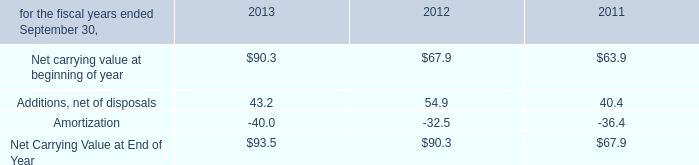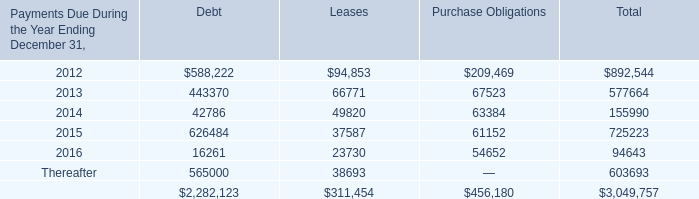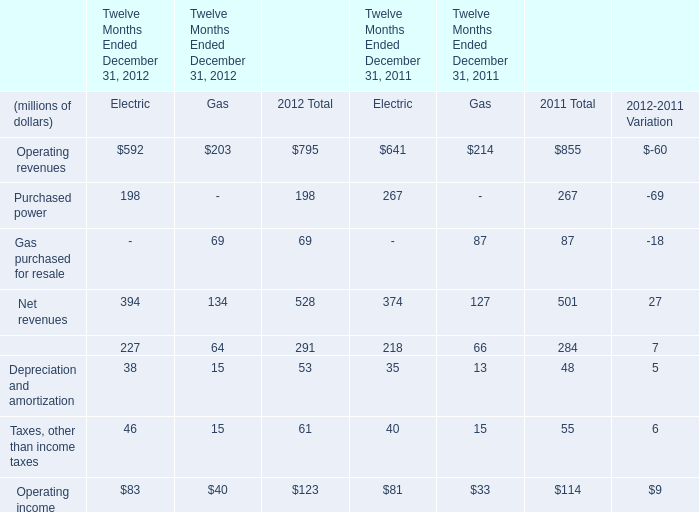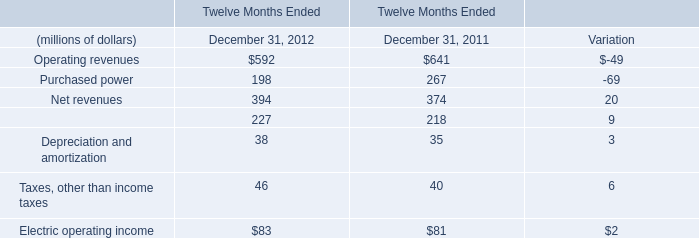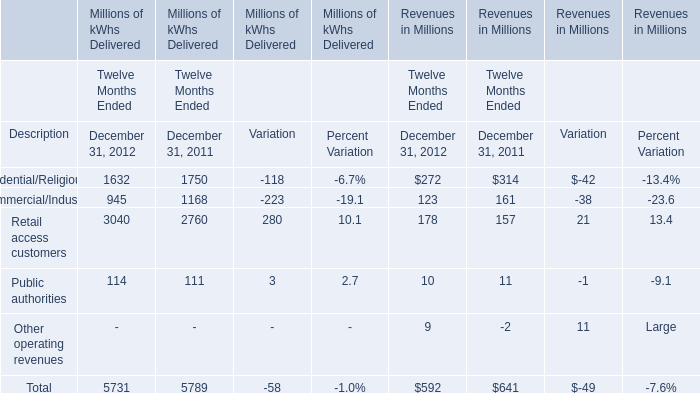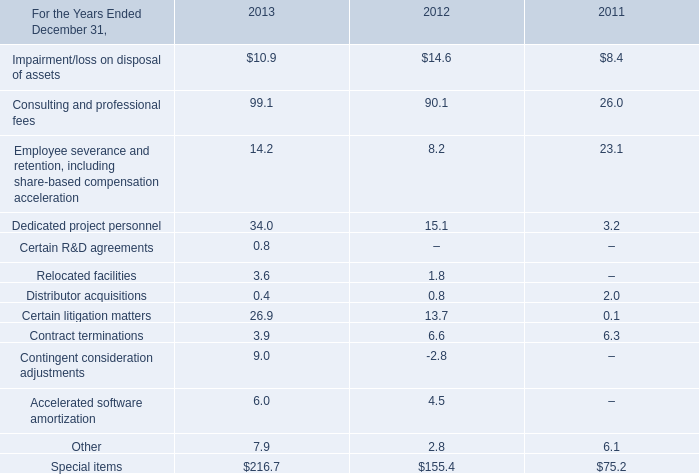what is the percent change in accelerated software amortization from 2012 to 2013? 
Computations: ((6.0 - 4.5) / 4.5)
Answer: 0.33333. 